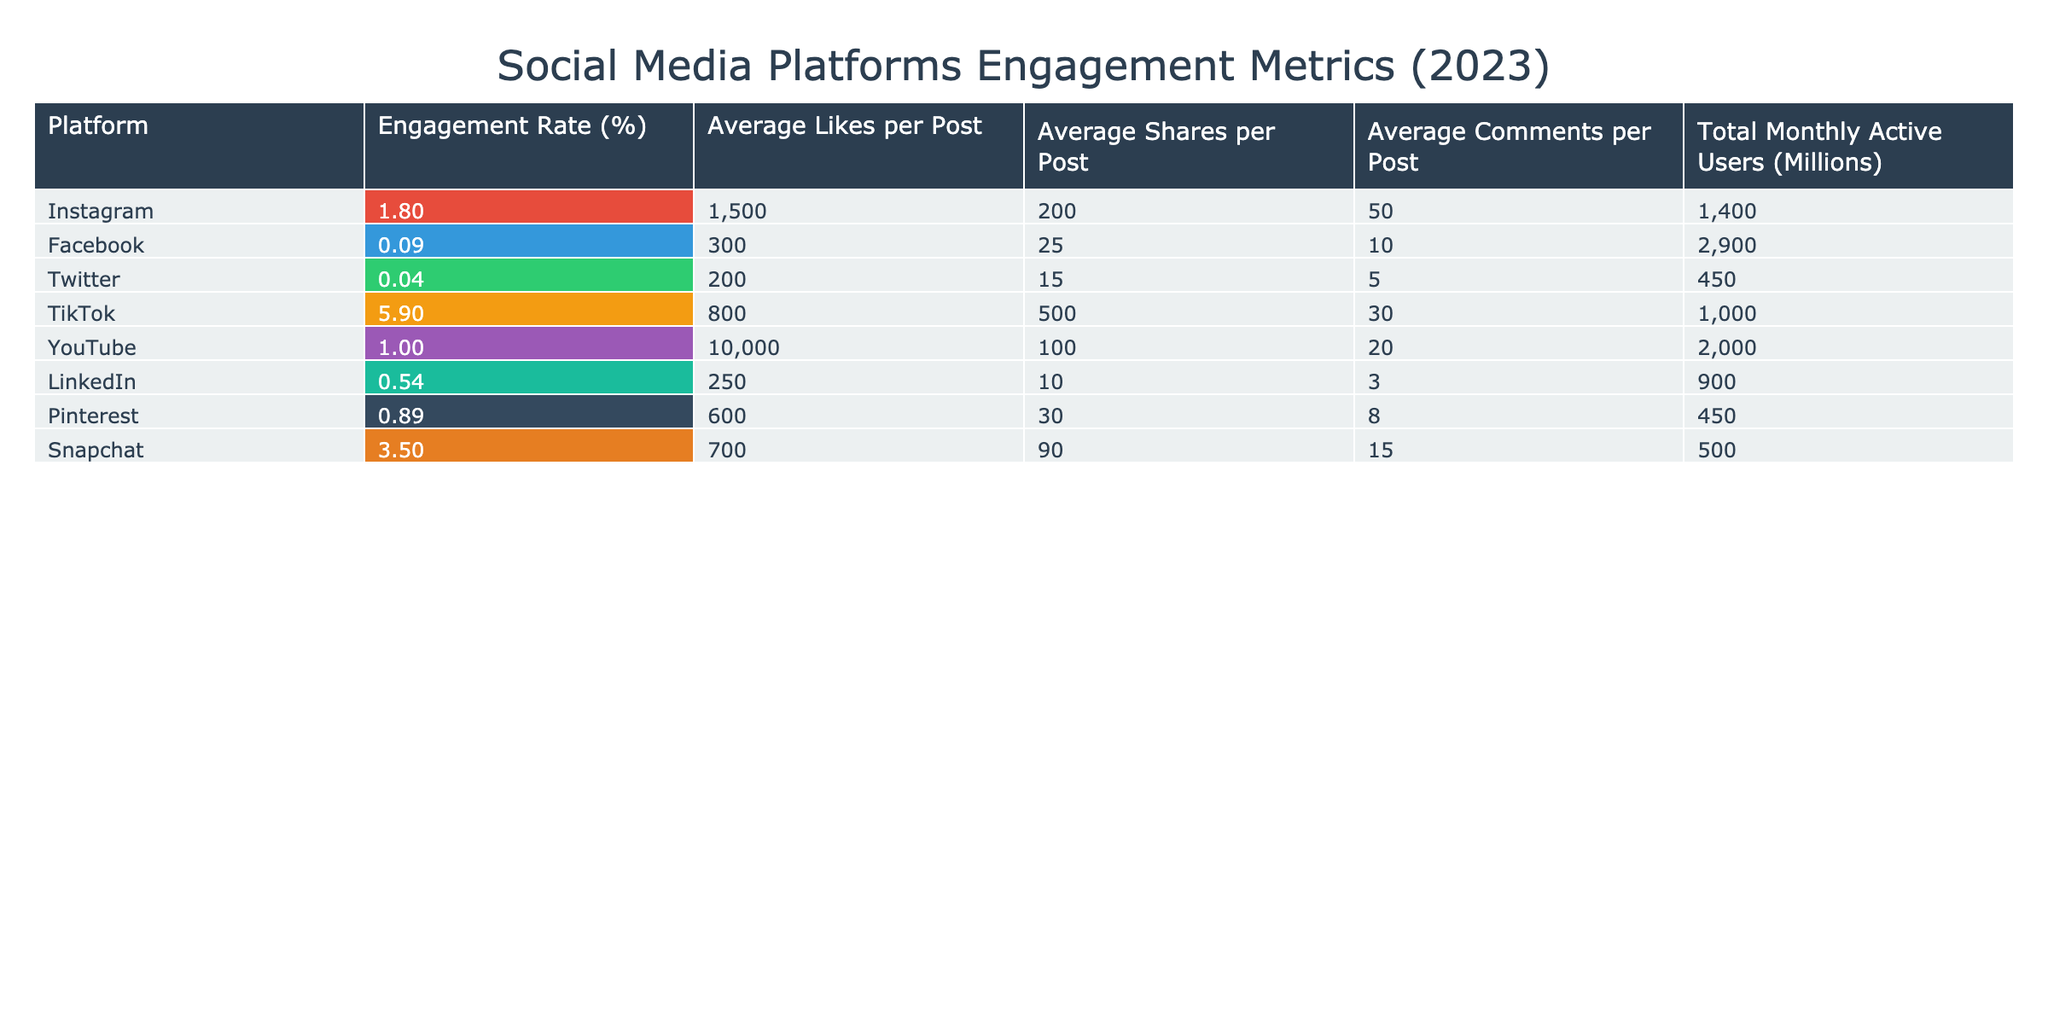What is the average engagement rate across all platforms? To find the average engagement rate, add the engagement rates from all platforms: (1.8 + 0.09 + 0.045 + 5.9 + 1.0 + 0.54 + 0.89 + 3.5) = 13.86. Then, divide by the number of platforms (8): 13.86 / 8 = 1.7325, which rounds to approximately 1.73.
Answer: 1.73 Which platform has the highest average likes per post? By looking at the average likes per post for each platform, Instagram has 1500, YouTube has 10000, TikTok has 800, and others have lower values. Thus, YouTube has the highest average likes per post.
Answer: YouTube Is the engagement rate for Facebook higher than that of LinkedIn? The engagement rate for Facebook is 0.09% and for LinkedIn is 0.54%. Since 0.09% is less than 0.54%, it is false that Facebook's engagement rate is higher than LinkedIn's.
Answer: No What is the total average number of comments per post for TikTok and Snapchat combined? The average comments per post for TikTok is 30 and for Snapchat is 15. To find the total average, add these two values: 30 + 15 = 45.
Answer: 45 Which platforms have an engagement rate greater than 1%? Checking the engagement rates: TikTok (5.9%), Instagram (1.8%), and YouTube (1.0%) are all above 1%. Thus, the platforms with engagement rates greater than 1% are TikTok, Instagram, and YouTube.
Answer: TikTok, Instagram, YouTube What is the difference in total monthly active users between Facebook and Snapchat? Facebook has 2900 million monthly active users, while Snapchat has 500 million. To find the difference: 2900 - 500 = 2400 million.
Answer: 2400 million Is it true that Instagram has more shares per post than Snapchat? Instagram has an average of 200 shares per post while Snapchat has 90 shares per post. Since 200 is greater than 90, it is true that Instagram has more shares per post than Snapchat.
Answer: Yes What is the average number of shares per post for all platforms? Adding the average shares for each platform gives: 200 (Instagram) + 25 (Facebook) + 15 (Twitter) + 500 (TikTok) + 100 (YouTube) + 10 (LinkedIn) + 30 (Pinterest) + 90 (Snapchat) = 970. Then, divide by the number of platforms (8): 970 / 8 = 121.25.
Answer: 121.25 Which platform has the lowest average comments per post? The average comments per post are as follows: Instagram (50), Facebook (10), Twitter (5), TikTok (30), YouTube (20), LinkedIn (3), Pinterest (8), and Snapchat (15). Twitter has the lowest average comments per post at 5.
Answer: Twitter 